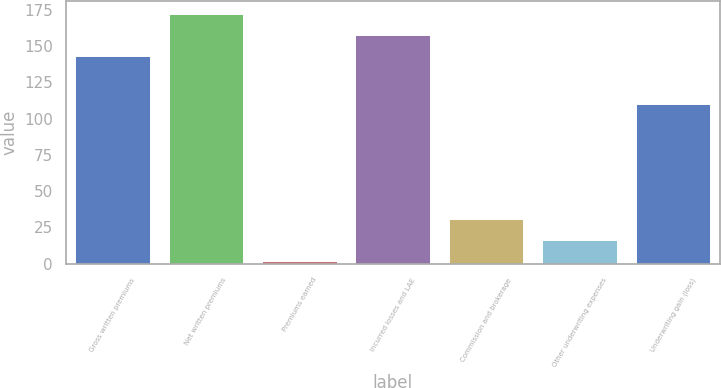<chart> <loc_0><loc_0><loc_500><loc_500><bar_chart><fcel>Gross written premiums<fcel>Net written premiums<fcel>Premiums earned<fcel>Incurred losses and LAE<fcel>Commission and brokerage<fcel>Other underwriting expenses<fcel>Underwriting gain (loss)<nl><fcel>143.2<fcel>172.56<fcel>1.8<fcel>157.88<fcel>31.16<fcel>16.48<fcel>110.2<nl></chart> 